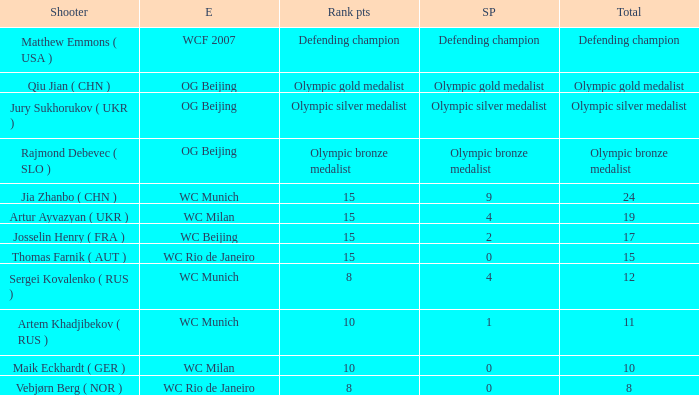Could you parse the entire table? {'header': ['Shooter', 'E', 'Rank pts', 'SP', 'Total'], 'rows': [['Matthew Emmons ( USA )', 'WCF 2007', 'Defending champion', 'Defending champion', 'Defending champion'], ['Qiu Jian ( CHN )', 'OG Beijing', 'Olympic gold medalist', 'Olympic gold medalist', 'Olympic gold medalist'], ['Jury Sukhorukov ( UKR )', 'OG Beijing', 'Olympic silver medalist', 'Olympic silver medalist', 'Olympic silver medalist'], ['Rajmond Debevec ( SLO )', 'OG Beijing', 'Olympic bronze medalist', 'Olympic bronze medalist', 'Olympic bronze medalist'], ['Jia Zhanbo ( CHN )', 'WC Munich', '15', '9', '24'], ['Artur Ayvazyan ( UKR )', 'WC Milan', '15', '4', '19'], ['Josselin Henry ( FRA )', 'WC Beijing', '15', '2', '17'], ['Thomas Farnik ( AUT )', 'WC Rio de Janeiro', '15', '0', '15'], ['Sergei Kovalenko ( RUS )', 'WC Munich', '8', '4', '12'], ['Artem Khadjibekov ( RUS )', 'WC Munich', '10', '1', '11'], ['Maik Eckhardt ( GER )', 'WC Milan', '10', '0', '10'], ['Vebjørn Berg ( NOR )', 'WC Rio de Janeiro', '8', '0', '8']]} With a total of 11, what is the score points? 1.0. 